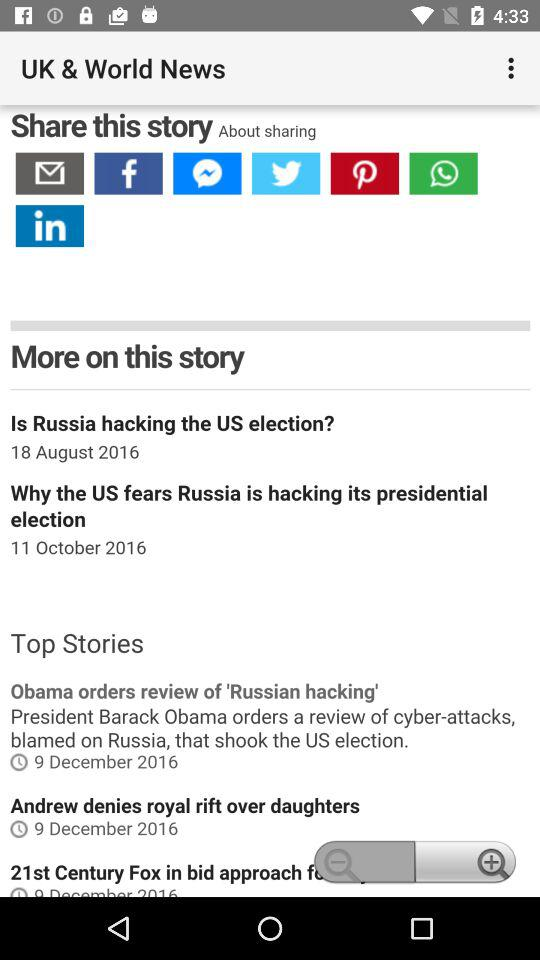What is the posted date of the top stories? The posted date of the top stories is December 9, 2016. 